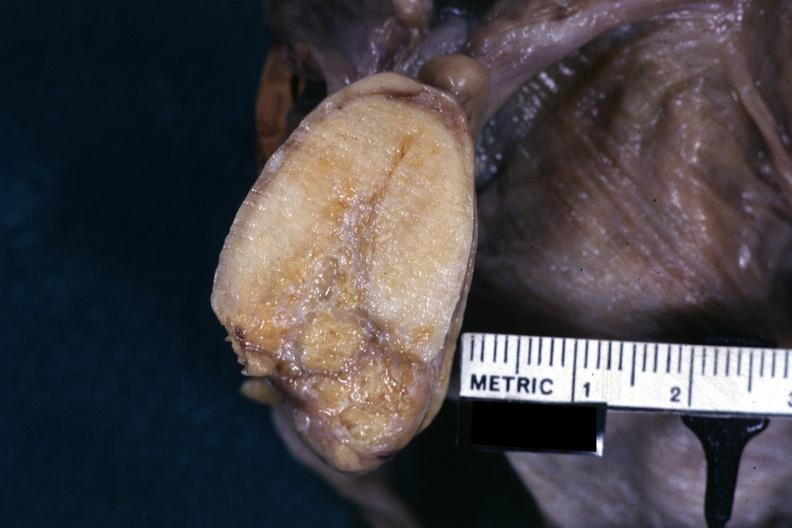where does this belong to?
Answer the question using a single word or phrase. Female reproductive system 